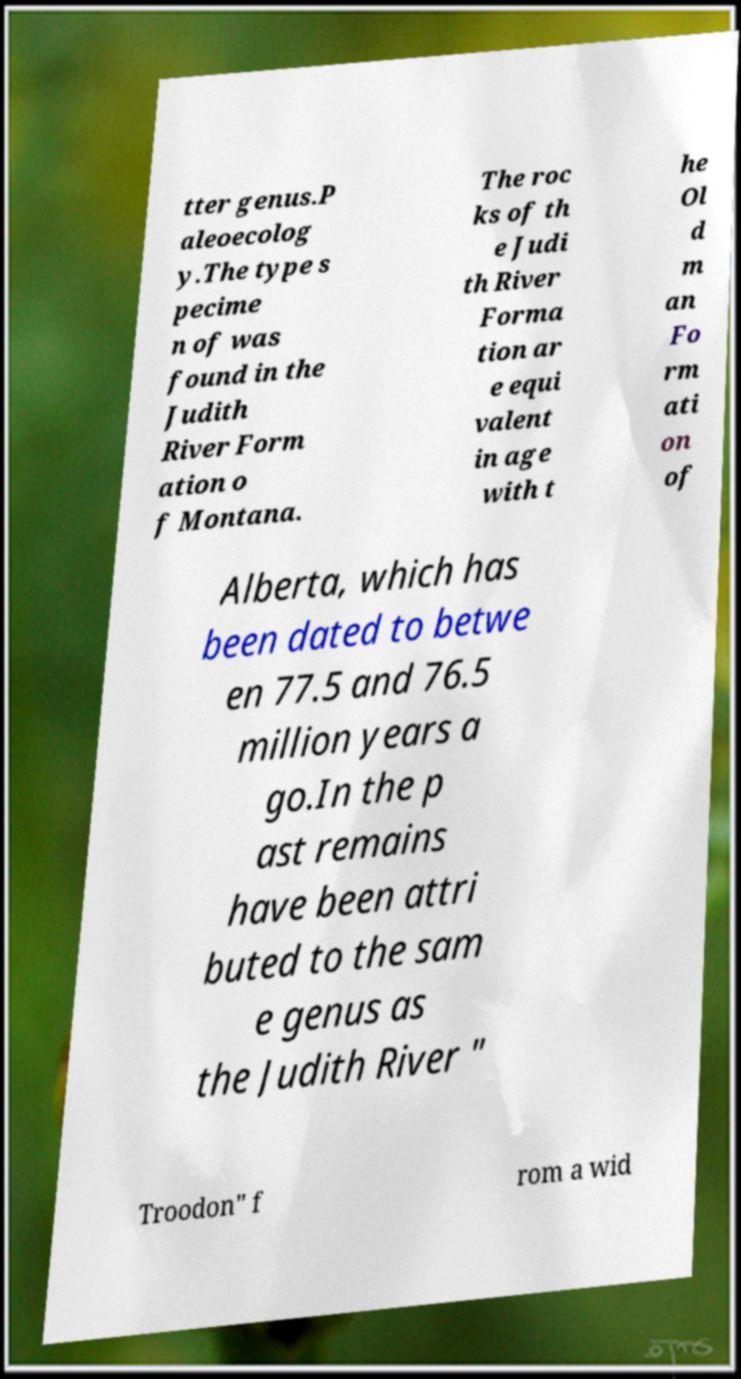There's text embedded in this image that I need extracted. Can you transcribe it verbatim? tter genus.P aleoecolog y.The type s pecime n of was found in the Judith River Form ation o f Montana. The roc ks of th e Judi th River Forma tion ar e equi valent in age with t he Ol d m an Fo rm ati on of Alberta, which has been dated to betwe en 77.5 and 76.5 million years a go.In the p ast remains have been attri buted to the sam e genus as the Judith River " Troodon" f rom a wid 